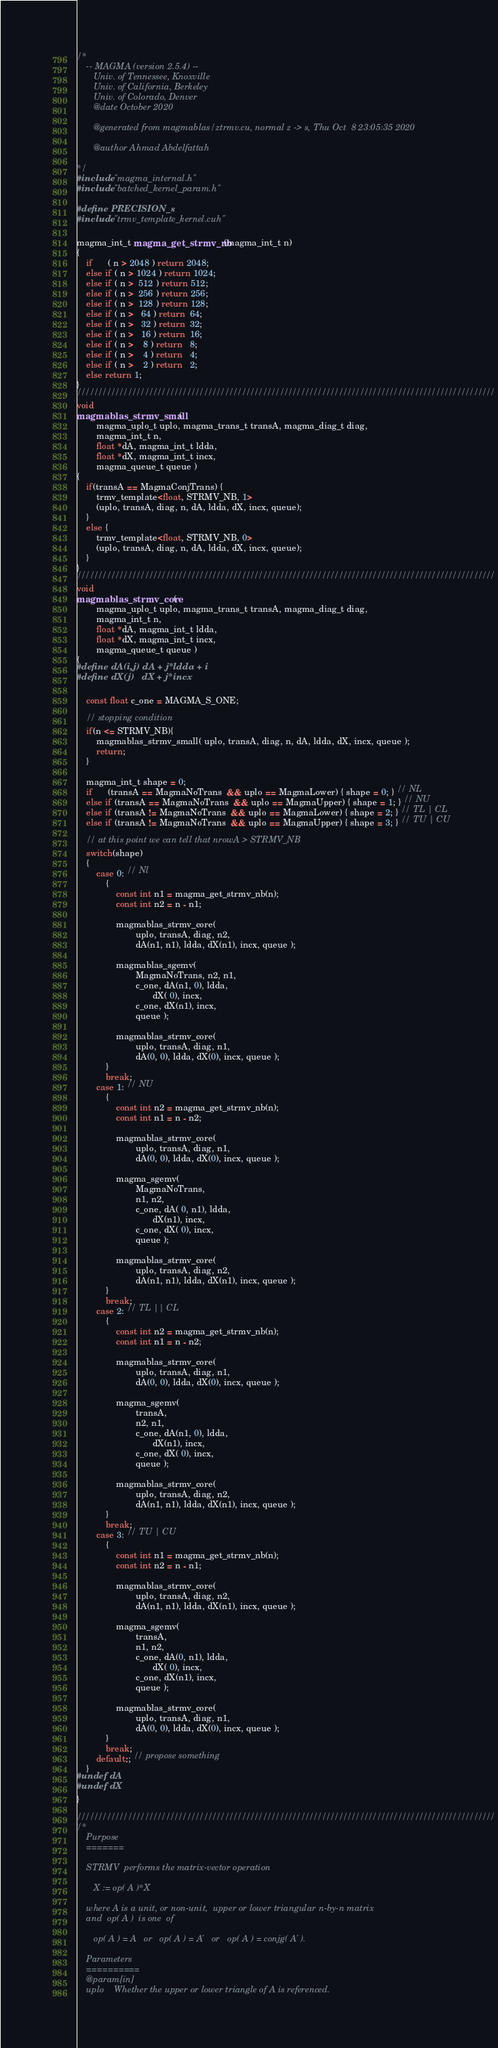Convert code to text. <code><loc_0><loc_0><loc_500><loc_500><_Cuda_>/*
    -- MAGMA (version 2.5.4) --
       Univ. of Tennessee, Knoxville
       Univ. of California, Berkeley
       Univ. of Colorado, Denver
       @date October 2020

       @generated from magmablas/ztrmv.cu, normal z -> s, Thu Oct  8 23:05:35 2020

       @author Ahmad Abdelfattah

*/
#include "magma_internal.h"
#include "batched_kernel_param.h"

#define PRECISION_s
#include "trmv_template_kernel.cuh"

magma_int_t magma_get_strmv_nb(magma_int_t n)
{
    if      ( n > 2048 ) return 2048;
    else if ( n > 1024 ) return 1024;
    else if ( n >  512 ) return 512;
    else if ( n >  256 ) return 256;
    else if ( n >  128 ) return 128;
    else if ( n >   64 ) return  64;
    else if ( n >   32 ) return  32;
    else if ( n >   16 ) return  16;
    else if ( n >    8 ) return   8;
    else if ( n >    4 ) return   4;
    else if ( n >    2 ) return   2;
    else return 1;
}
///////////////////////////////////////////////////////////////////////////////////////////////////
void
magmablas_strmv_small(
        magma_uplo_t uplo, magma_trans_t transA, magma_diag_t diag,
        magma_int_t n,
        float *dA, magma_int_t ldda,
        float *dX, magma_int_t incx,
        magma_queue_t queue )
{
    if(transA == MagmaConjTrans) {
        trmv_template<float, STRMV_NB, 1>
        (uplo, transA, diag, n, dA, ldda, dX, incx, queue);
    }
    else {
        trmv_template<float, STRMV_NB, 0>
        (uplo, transA, diag, n, dA, ldda, dX, incx, queue);
    }
}
///////////////////////////////////////////////////////////////////////////////////////////////////
void
magmablas_strmv_core(
        magma_uplo_t uplo, magma_trans_t transA, magma_diag_t diag,
        magma_int_t n,
        float *dA, magma_int_t ldda,
        float *dX, magma_int_t incx,
        magma_queue_t queue )
{
#define dA(i,j) dA + j*ldda + i
#define dX(j)   dX + j*incx

    const float c_one = MAGMA_S_ONE;

    // stopping condition
    if(n <= STRMV_NB){
        magmablas_strmv_small( uplo, transA, diag, n, dA, ldda, dX, incx, queue );
        return;
    }

    magma_int_t shape = 0;
    if      (transA == MagmaNoTrans  && uplo == MagmaLower) { shape = 0; } // NL
    else if (transA == MagmaNoTrans  && uplo == MagmaUpper) { shape = 1; } // NU
    else if (transA != MagmaNoTrans  && uplo == MagmaLower) { shape = 2; } // TL | CL
    else if (transA != MagmaNoTrans  && uplo == MagmaUpper) { shape = 3; } // TU | CU

    // at this point we can tell that nrowA > STRMV_NB
    switch(shape)
    {
        case 0: // Nl
            {
                const int n1 = magma_get_strmv_nb(n);
                const int n2 = n - n1;

                magmablas_strmv_core(
                        uplo, transA, diag, n2,
                        dA(n1, n1), ldda, dX(n1), incx, queue );

                magmablas_sgemv(
                        MagmaNoTrans, n2, n1,
                        c_one, dA(n1, 0), ldda,
                               dX( 0), incx,
                        c_one, dX(n1), incx,
                        queue );

                magmablas_strmv_core(
                        uplo, transA, diag, n1,
                        dA(0, 0), ldda, dX(0), incx, queue );
            }
            break;
        case 1: // NU
            {
                const int n2 = magma_get_strmv_nb(n);
                const int n1 = n - n2;

                magmablas_strmv_core(
                        uplo, transA, diag, n1,
                        dA(0, 0), ldda, dX(0), incx, queue );

                magma_sgemv(
                        MagmaNoTrans,
                        n1, n2,
                        c_one, dA( 0, n1), ldda,
                               dX(n1), incx,
                        c_one, dX( 0), incx,
                        queue );

                magmablas_strmv_core(
                        uplo, transA, diag, n2,
                        dA(n1, n1), ldda, dX(n1), incx, queue );
            }
            break;
        case 2: // TL || CL
            {
                const int n2 = magma_get_strmv_nb(n);
                const int n1 = n - n2;

                magmablas_strmv_core(
                        uplo, transA, diag, n1,
                        dA(0, 0), ldda, dX(0), incx, queue );

                magma_sgemv(
                        transA,
                        n2, n1,
                        c_one, dA(n1, 0), ldda,
                               dX(n1), incx,
                        c_one, dX( 0), incx,
                        queue );

                magmablas_strmv_core(
                        uplo, transA, diag, n2,
                        dA(n1, n1), ldda, dX(n1), incx, queue );
            }
            break;
        case 3: // TU | CU
            {
                const int n1 = magma_get_strmv_nb(n);
                const int n2 = n - n1;

                magmablas_strmv_core(
                        uplo, transA, diag, n2,
                        dA(n1, n1), ldda, dX(n1), incx, queue );

                magma_sgemv(
                        transA,
                        n1, n2,
                        c_one, dA(0, n1), ldda,
                               dX( 0), incx,
                        c_one, dX(n1), incx,
                        queue );

                magmablas_strmv_core(
                        uplo, transA, diag, n1,
                        dA(0, 0), ldda, dX(0), incx, queue );
            }
            break;
        default:; // propose something
    }
#undef dA
#undef dX
}

///////////////////////////////////////////////////////////////////////////////////////////////////
/*
    Purpose
    =======

    STRMV  performs the matrix-vector operation

       X := op( A )*X

    where A is a unit, or non-unit,  upper or lower triangular n-by-n matrix
    and  op( A )  is one  of

       op( A ) = A   or   op( A ) = A'   or   op( A ) = conjg( A' ).

    Parameters
    ==========
    @param[in]
    uplo    Whether the upper or lower triangle of A is referenced.
</code> 